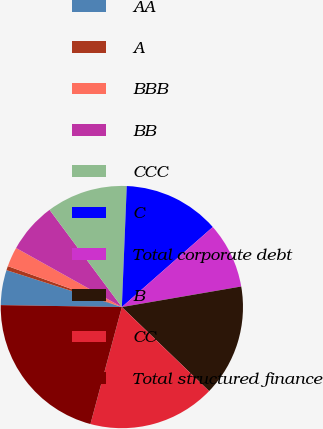Convert chart. <chart><loc_0><loc_0><loc_500><loc_500><pie_chart><fcel>AA<fcel>A<fcel>BBB<fcel>BB<fcel>CCC<fcel>C<fcel>Total corporate debt<fcel>B<fcel>CC<fcel>Total structured finance<nl><fcel>4.67%<fcel>0.56%<fcel>2.62%<fcel>6.72%<fcel>10.82%<fcel>12.87%<fcel>8.77%<fcel>14.92%<fcel>16.97%<fcel>21.08%<nl></chart> 